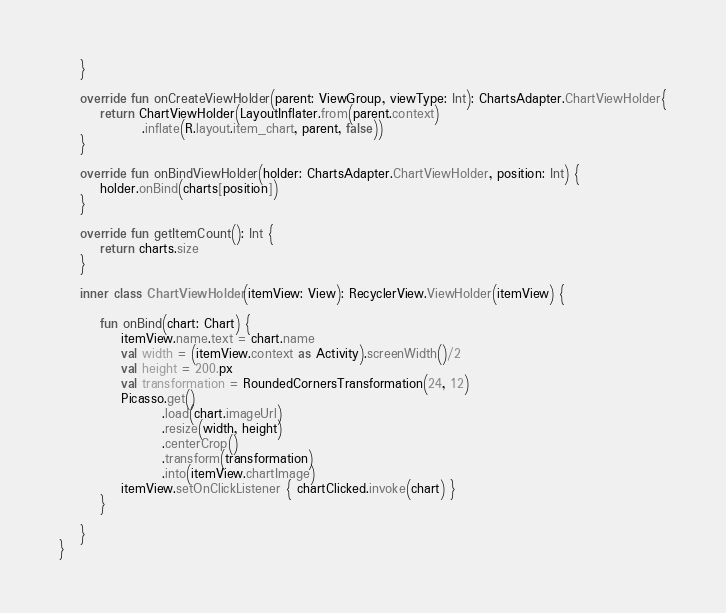<code> <loc_0><loc_0><loc_500><loc_500><_Kotlin_>    }

    override fun onCreateViewHolder(parent: ViewGroup, viewType: Int): ChartsAdapter.ChartViewHolder{
        return ChartViewHolder(LayoutInflater.from(parent.context)
                .inflate(R.layout.item_chart, parent, false))
    }

    override fun onBindViewHolder(holder: ChartsAdapter.ChartViewHolder, position: Int) {
        holder.onBind(charts[position])
    }

    override fun getItemCount(): Int {
        return charts.size
    }

    inner class ChartViewHolder(itemView: View): RecyclerView.ViewHolder(itemView) {

        fun onBind(chart: Chart) {
            itemView.name.text = chart.name
            val width = (itemView.context as Activity).screenWidth()/2
            val height = 200.px
            val transformation = RoundedCornersTransformation(24, 12)
            Picasso.get()
                    .load(chart.imageUrl)
                    .resize(width, height)
                    .centerCrop()
                    .transform(transformation)
                    .into(itemView.chartImage)
            itemView.setOnClickListener { chartClicked.invoke(chart) }
        }

    }
}</code> 